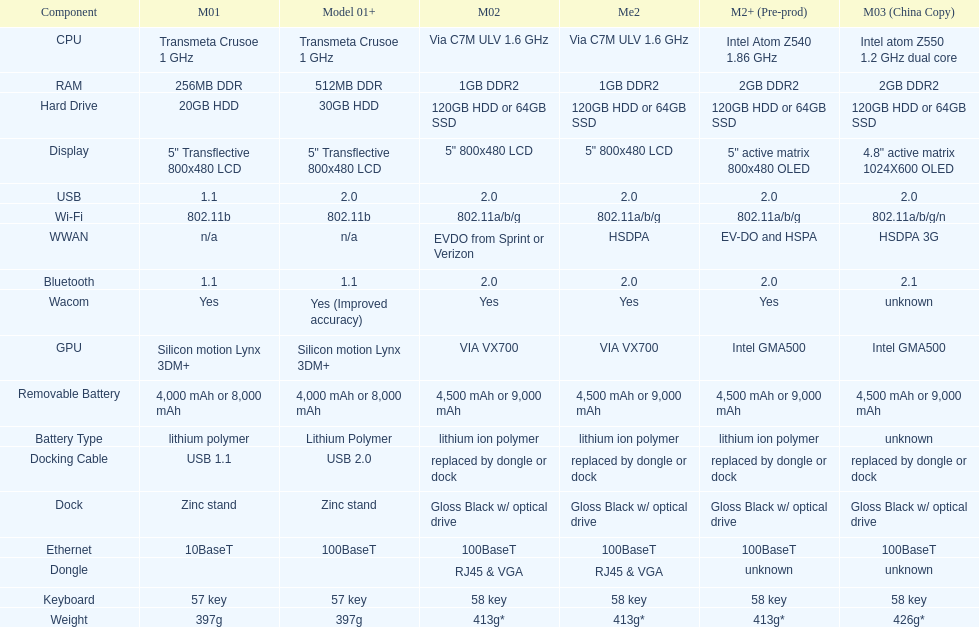Are there at least 13 different components on the chart? Yes. 